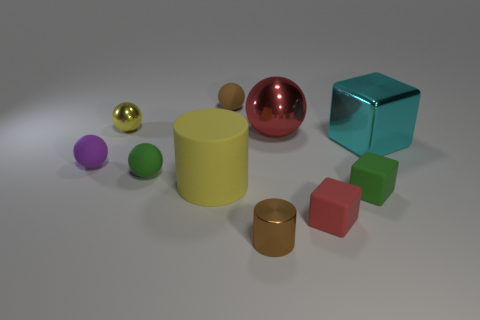Are there any rubber things in front of the cyan shiny cube?
Your response must be concise. Yes. What number of other things are the same size as the red shiny sphere?
Offer a very short reply. 2. There is a small object that is both behind the cyan metallic thing and in front of the brown rubber thing; what is its material?
Your response must be concise. Metal. There is a small metallic object that is behind the tiny purple thing; is its shape the same as the small green thing to the left of the small red matte object?
Your response must be concise. Yes. Is there any other thing that has the same material as the brown ball?
Your response must be concise. Yes. What is the shape of the big cyan metal object that is on the right side of the tiny matte sphere on the left side of the tiny shiny object behind the large cyan shiny cube?
Offer a terse response. Cube. What number of other things are there of the same shape as the large red metal object?
Keep it short and to the point. 4. The metallic cylinder that is the same size as the purple sphere is what color?
Provide a succinct answer. Brown. What number of spheres are either large purple objects or cyan objects?
Ensure brevity in your answer.  0. How many small rubber spheres are there?
Offer a very short reply. 3. 